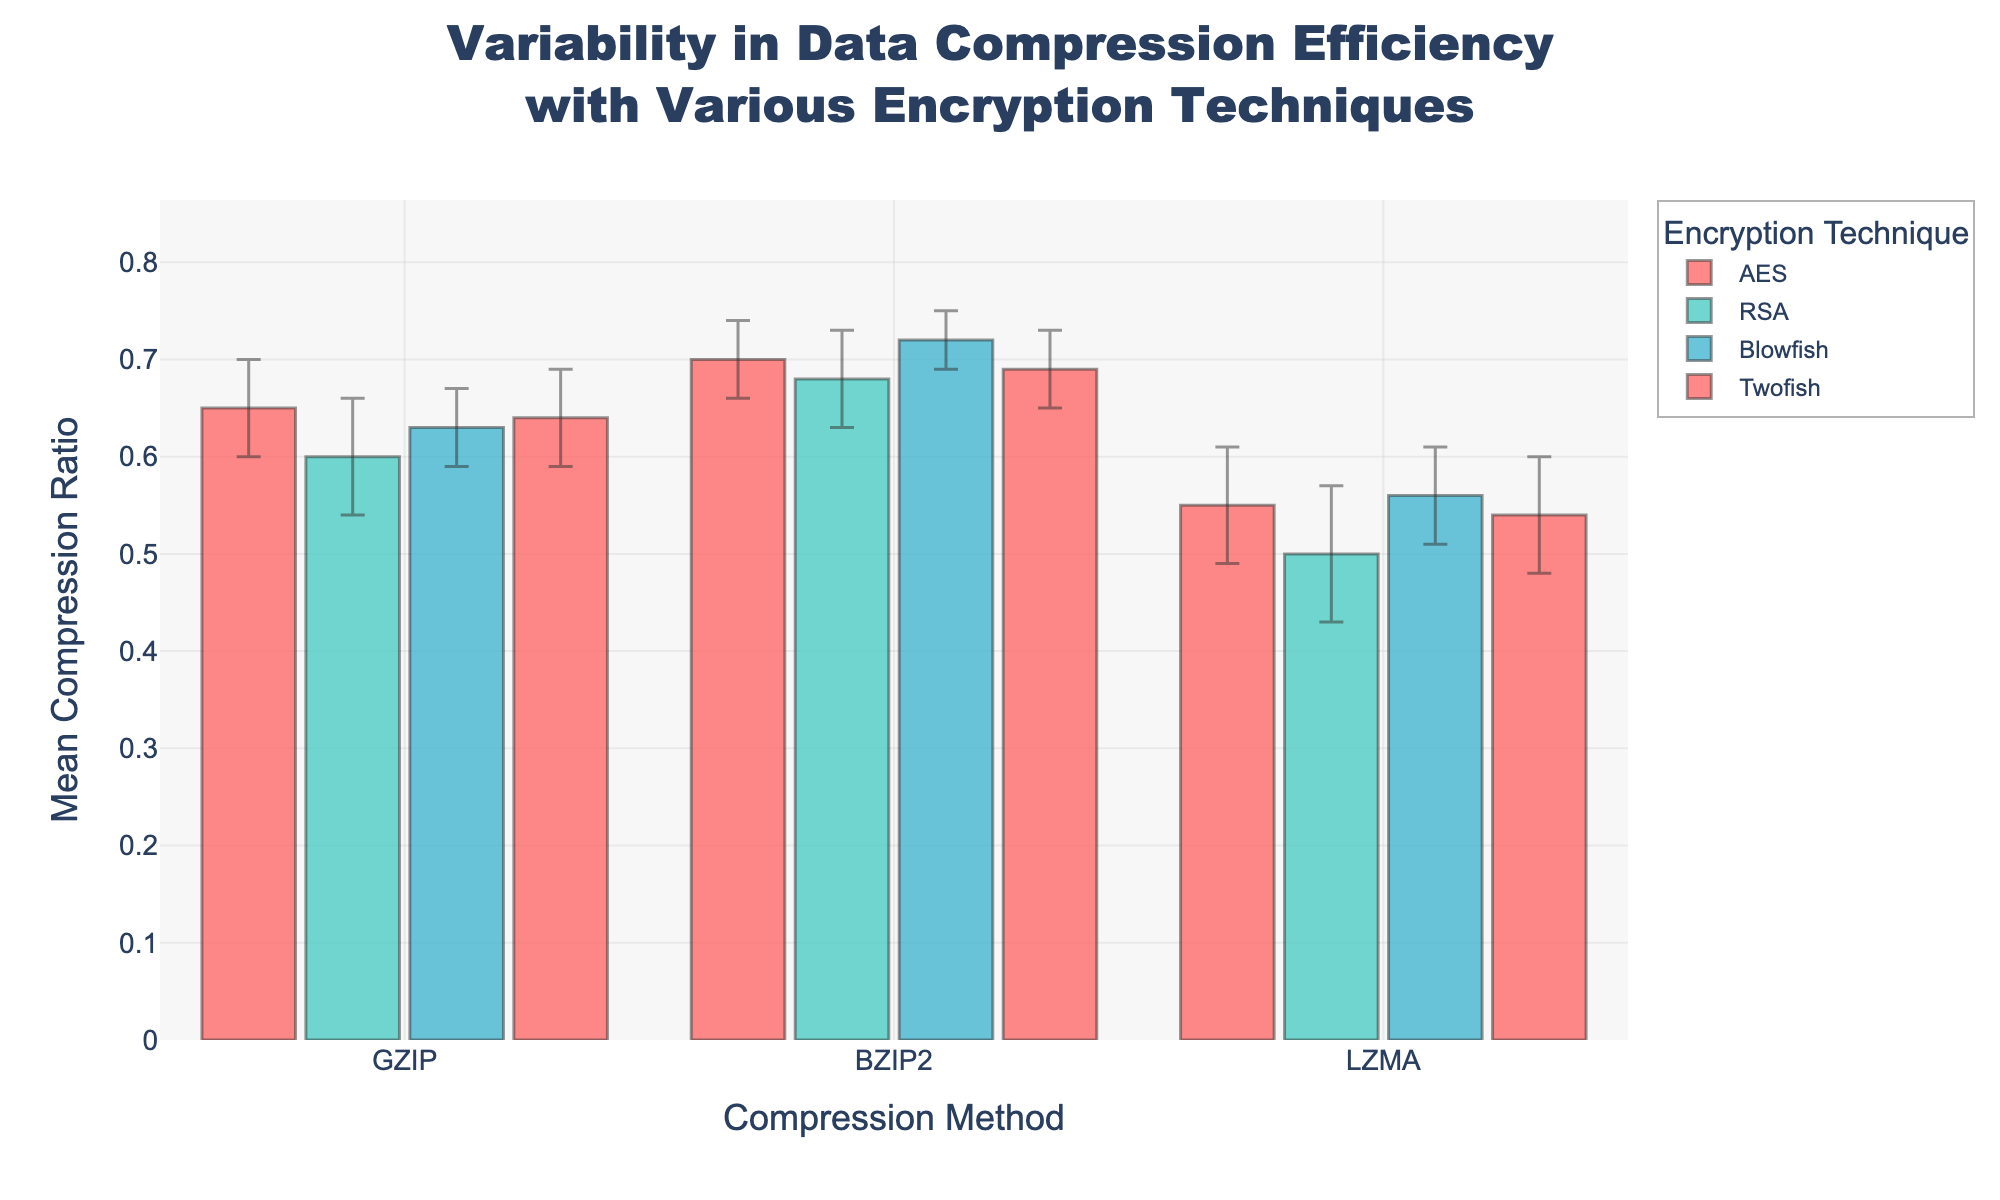What is the title of the figure? The title is displayed at the top of the figure. It details the main subject of the plot.
Answer: Variability in Data Compression Efficiency with Various Encryption Techniques Which encryption technique has the highest mean compression ratio with the LZMA compression method? To determine this, locate the bars corresponding to the LZMA compression method and compare their heights. Blowfish has the tallest bar in the LZMA category.
Answer: Blowfish What is the mean compression ratio for the AES technique using the GZIP method? Find the bar corresponding to AES and GZIP. The height of this bar represents the mean compression ratio.
Answer: 0.65 Which compression method shows the least variability in compression ratio for RSA encryption? Look for the smallest error bars among the bars corresponding to RSA. The BZIP2 method for RSA encryption shows the least error.
Answer: BZIP2 Which encryption technique provides a higher average compression ratio across all compression methods compared to AES? Calculate the average compression ratio for all compression methods for each encryption technique and compare them to AES. Blowfish shows higher mean values across its compression methods.
Answer: Blowfish What is the range of the mean compression ratio values for the GZIP method across all encryption techniques? Identify the highest and lowest bars for the GZIP method and calculate the range. The highest is AES with 0.65, and the lowest is RSA with 0.60, so the range is 0.65 - 0.60.
Answer: 0.05 How does the mean compression ratio for Blowfish with GZIP compare to Twofish with BZIP2? Compare the height of the bar corresponding to Blowfish with GZIP against the height of the bar for Twofish with BZIP2. Blowfish with GZIP has a mean compression ratio of 0.63, whereas Twofish with BZIP2 has 0.69.
Answer: Blowfish with GZIP is lower Which compression method shows the highest mean compression ratio overall? Compare the highest bars among each compression method. BZIP2 under Blowfish has the highest mean compression ratio.
Answer: BZIP2 What is the mean compression ratio for the LZMA method combined with RSA encryption, including its variability? Locate the bar for RSA with LZMA and observe its height and error bar. The mean compression ratio is 0.50, and the error bar represents a standard deviation of 0.07.
Answer: 0.50 ± 0.07 